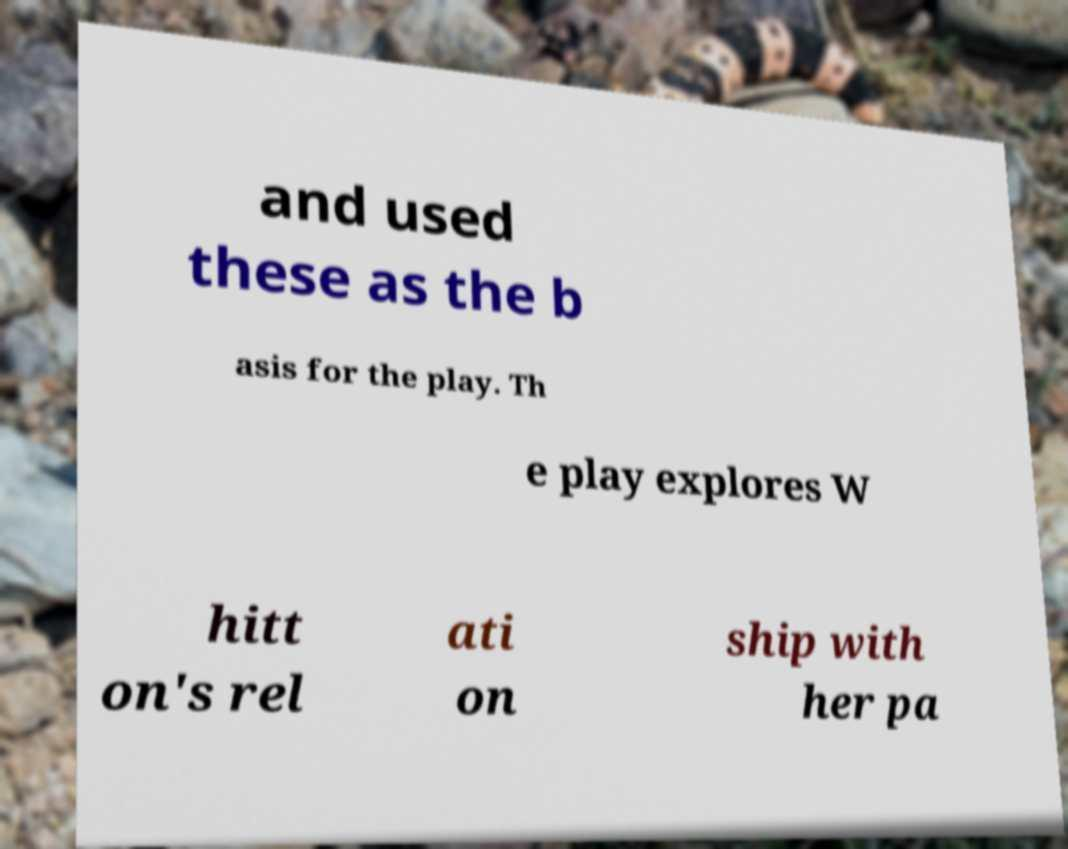For documentation purposes, I need the text within this image transcribed. Could you provide that? and used these as the b asis for the play. Th e play explores W hitt on's rel ati on ship with her pa 